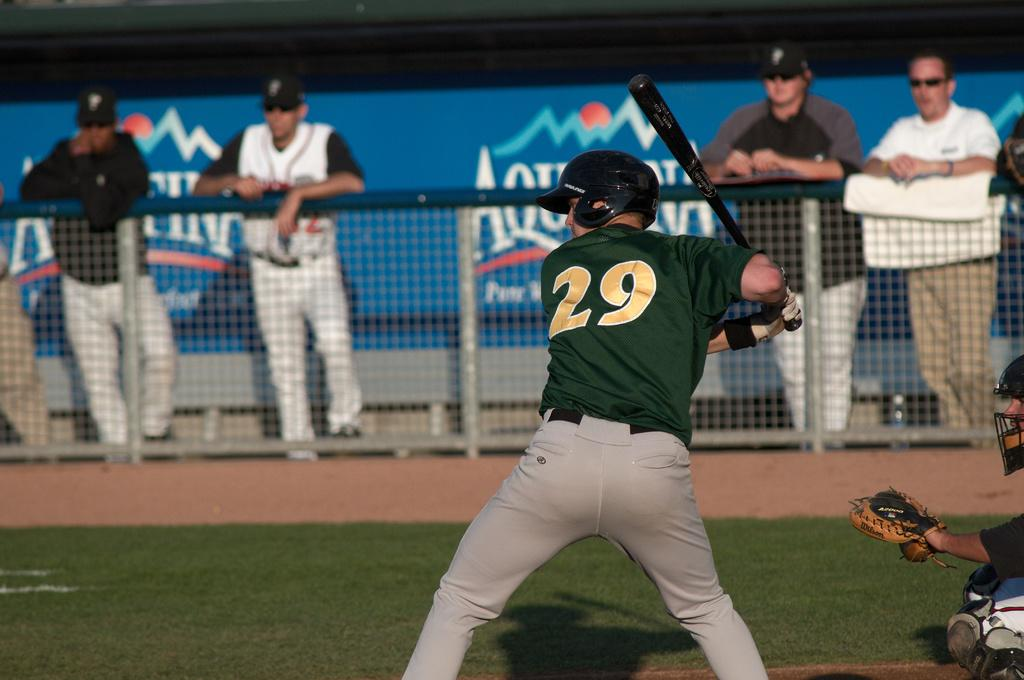What is one person holding in the image? One person is holding a bat in the image. What protective gear are the persons wearing? Both persons are wearing helmets in the image. Can you describe the attire of one of the persons? One person is wearing gloves in the image. What can be seen behind the mesh in the image? There are people visible at the backside of the mesh, and there is a hoarding visible as well. What type of argument is taking place between the two persons in the image? There is no indication of an argument in the image; both persons are wearing helmets and one is holding a bat, which suggests they might be participating in a sport. What is the mouth of the person holding the bat doing in the image? There is no information about the mouth of the person holding the bat in the image, as it is not visible or mentioned in the provided facts. 